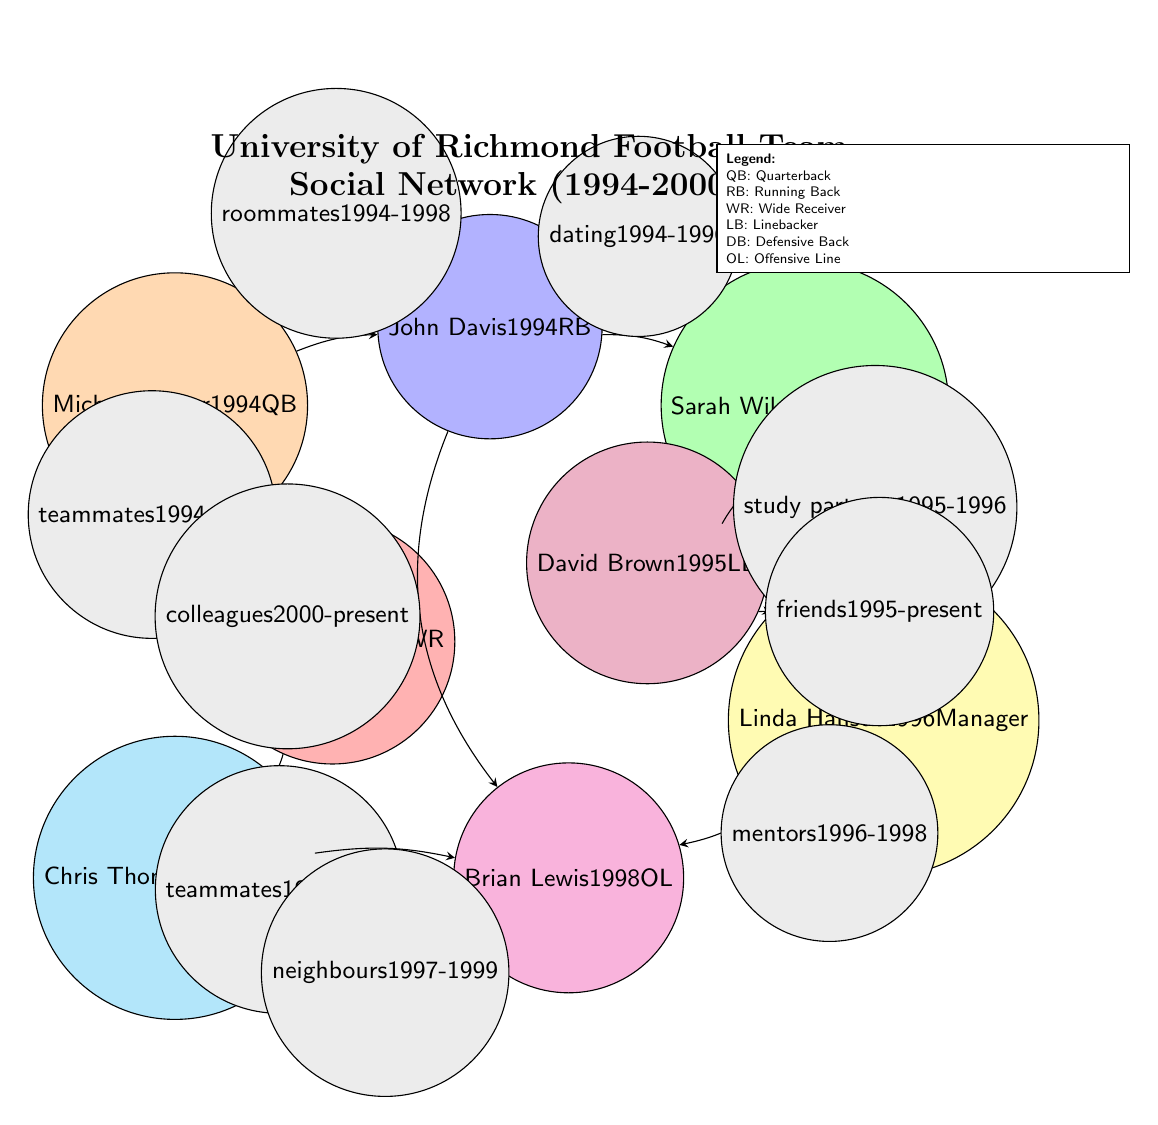What is the relationship between Michael Carter and John Davis? The edge between Michael Carter and John Davis indicates that they were roommates from 1994 to 1998. This is shown by the label above the arrow connecting the two nodes.
Answer: roommates How many nodes are there in the sociogram? The diagram displays a total of 8 distinct nodes representing different individuals in the network. By counting all the circles, we confirm there are 8.
Answer: 8 What type of relationship do Chris Thompson and Brian Lewis have? The edge connecting Chris Thompson and Brian Lewis describes their relationship as neighbors from 1997 to 1999. This can be observed by looking at the label below the arrow connecting their nodes.
Answer: neighbours Which player has the longest persistent friendship in the diagram? David Brown and Linda Hansen have a friendship labeled as "friends" from 1995 to the present, indicating the longest duration of friendship noted in the sociogram. The label on their connection specifies this ongoing relationship.
Answer: friends From which year to which year did John Davis and Sarah Wilson's relationship last? The connection between John Davis and Sarah Wilson describes their dating relationship from 1994 to 1996, as indicated by the label on the edge connecting their nodes.
Answer: 1994-1996 Who is the trainer related to the quarterback in the diagram? Sarah Wilson is identified as the trainer, and the sociogram shows that she is connected to Michael Carter, the quarterback, through a labeled relationship indicating they were teammates from 1994 to 1998.
Answer: Sarah Wilson What role does Linda Hansen have in the network? Linda Hansen is designated as the manager in the sociogram, which can be identified at her node where her title is displayed below her name.
Answer: Manager Which two nodes have a relationship defined as "teammates"? The connection between Michael Carter and Emily Smith is labeled as teammates from 1994 to 1998 and the connection between Emily Smith and Chris Thompson also indicates a teammates relationship from 1996 to 1998. Both relationships highlight the term "teammates."
Answer: Michael Carter and Emily Smith, Emily Smith and Chris Thompson 